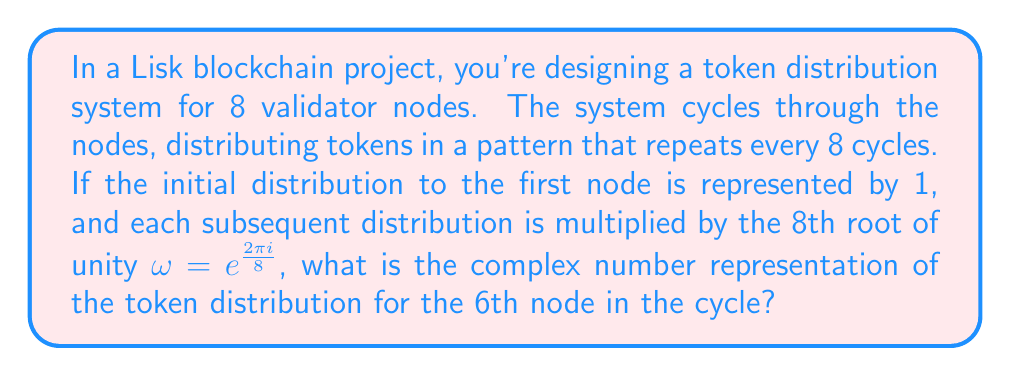Teach me how to tackle this problem. Let's approach this step-by-step:

1) The 8th root of unity is given by $\omega = e^{\frac{2\pi i}{8}}$.

2) Each subsequent distribution is multiplied by $\omega$, so the pattern goes:
   1, $\omega$, $\omega^2$, $\omega^3$, $\omega^4$, $\omega^5$, $\omega^6$, $\omega^7$

3) We're asked about the 6th node, which corresponds to $\omega^5$.

4) To calculate $\omega^5$:
   $$\omega^5 = (e^{\frac{2\pi i}{8}})^5 = e^{\frac{10\pi i}{8}} = e^{\frac{5\pi i}{4}}$$

5) We can express this in terms of sine and cosine:
   $$e^{\frac{5\pi i}{4}} = \cos(\frac{5\pi}{4}) + i\sin(\frac{5\pi}{4})$$

6) Calculating these values:
   $$\cos(\frac{5\pi}{4}) = -\frac{\sqrt{2}}{2}$$
   $$\sin(\frac{5\pi}{4}) = -\frac{\sqrt{2}}{2}$$

7) Therefore, the complex number representation is:
   $$-\frac{\sqrt{2}}{2} - \frac{\sqrt{2}}{2}i$$

8) This can be simplified to:
   $$-\frac{\sqrt{2}}{2}(1 + i)$$
Answer: $-\frac{\sqrt{2}}{2}(1 + i)$ 